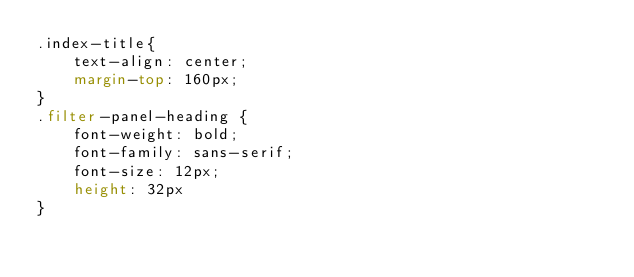<code> <loc_0><loc_0><loc_500><loc_500><_CSS_>.index-title{
    text-align: center;
    margin-top: 160px;
}
.filter-panel-heading {
    font-weight: bold;
    font-family: sans-serif;
    font-size: 12px;
    height: 32px
}
</code> 